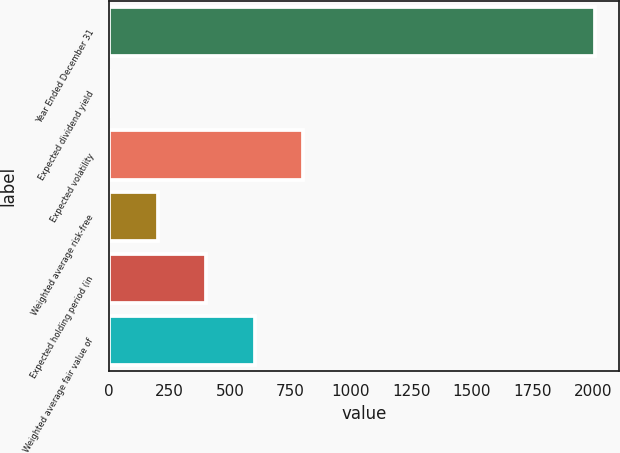<chart> <loc_0><loc_0><loc_500><loc_500><bar_chart><fcel>Year Ended December 31<fcel>Expected dividend yield<fcel>Expected volatility<fcel>Weighted average risk-free<fcel>Expected holding period (in<fcel>Weighted average fair value of<nl><fcel>2008<fcel>0.6<fcel>803.56<fcel>201.34<fcel>402.08<fcel>602.82<nl></chart> 